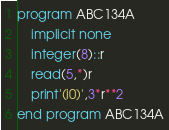Convert code to text. <code><loc_0><loc_0><loc_500><loc_500><_FORTRAN_>program ABC134A
    implicit none
    integer(8)::r
    read(5,*)r
    print'(i0)',3*r**2
end program ABC134A</code> 